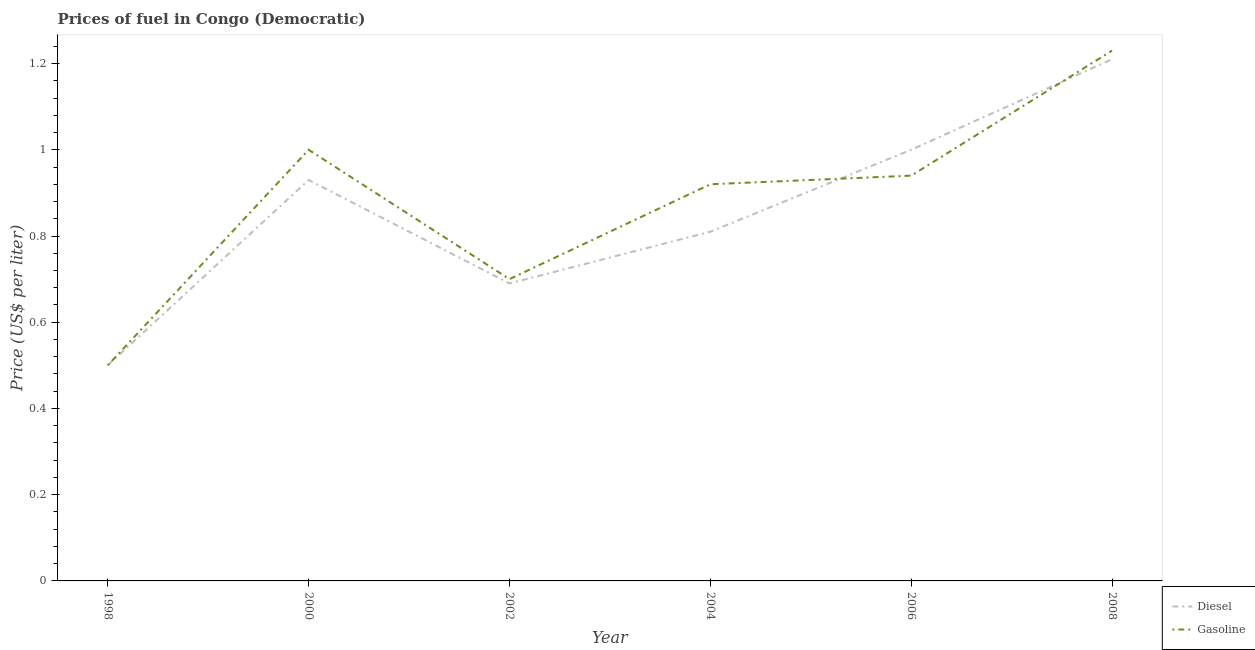Does the line corresponding to gasoline price intersect with the line corresponding to diesel price?
Your response must be concise. Yes. Is the number of lines equal to the number of legend labels?
Offer a very short reply. Yes. What is the gasoline price in 2000?
Your answer should be compact. 1. Across all years, what is the maximum diesel price?
Provide a short and direct response. 1.21. Across all years, what is the minimum gasoline price?
Provide a short and direct response. 0.5. What is the total diesel price in the graph?
Ensure brevity in your answer.  5.14. What is the difference between the gasoline price in 1998 and that in 2004?
Ensure brevity in your answer.  -0.42. What is the difference between the diesel price in 2002 and the gasoline price in 2006?
Offer a very short reply. -0.25. What is the average diesel price per year?
Make the answer very short. 0.86. In the year 2006, what is the difference between the gasoline price and diesel price?
Offer a terse response. -0.06. In how many years, is the gasoline price greater than 1.08 US$ per litre?
Ensure brevity in your answer.  1. What is the ratio of the diesel price in 1998 to that in 2008?
Offer a terse response. 0.41. Is the gasoline price in 1998 less than that in 2002?
Your answer should be compact. Yes. What is the difference between the highest and the second highest diesel price?
Make the answer very short. 0.21. What is the difference between the highest and the lowest diesel price?
Make the answer very short. 0.71. Does the gasoline price monotonically increase over the years?
Your response must be concise. No. Are the values on the major ticks of Y-axis written in scientific E-notation?
Give a very brief answer. No. Does the graph contain any zero values?
Provide a short and direct response. No. Does the graph contain grids?
Provide a succinct answer. No. Where does the legend appear in the graph?
Make the answer very short. Bottom right. How are the legend labels stacked?
Ensure brevity in your answer.  Vertical. What is the title of the graph?
Your response must be concise. Prices of fuel in Congo (Democratic). What is the label or title of the Y-axis?
Your answer should be compact. Price (US$ per liter). What is the Price (US$ per liter) in Gasoline in 1998?
Keep it short and to the point. 0.5. What is the Price (US$ per liter) of Diesel in 2000?
Provide a succinct answer. 0.93. What is the Price (US$ per liter) in Diesel in 2002?
Your answer should be very brief. 0.69. What is the Price (US$ per liter) of Diesel in 2004?
Offer a terse response. 0.81. What is the Price (US$ per liter) of Diesel in 2008?
Provide a short and direct response. 1.21. What is the Price (US$ per liter) of Gasoline in 2008?
Your answer should be compact. 1.23. Across all years, what is the maximum Price (US$ per liter) of Diesel?
Make the answer very short. 1.21. Across all years, what is the maximum Price (US$ per liter) of Gasoline?
Your answer should be compact. 1.23. What is the total Price (US$ per liter) of Diesel in the graph?
Keep it short and to the point. 5.14. What is the total Price (US$ per liter) in Gasoline in the graph?
Make the answer very short. 5.29. What is the difference between the Price (US$ per liter) in Diesel in 1998 and that in 2000?
Your answer should be very brief. -0.43. What is the difference between the Price (US$ per liter) of Diesel in 1998 and that in 2002?
Your answer should be compact. -0.19. What is the difference between the Price (US$ per liter) in Gasoline in 1998 and that in 2002?
Your response must be concise. -0.2. What is the difference between the Price (US$ per liter) of Diesel in 1998 and that in 2004?
Your answer should be compact. -0.31. What is the difference between the Price (US$ per liter) in Gasoline in 1998 and that in 2004?
Provide a short and direct response. -0.42. What is the difference between the Price (US$ per liter) of Gasoline in 1998 and that in 2006?
Provide a short and direct response. -0.44. What is the difference between the Price (US$ per liter) in Diesel in 1998 and that in 2008?
Your answer should be very brief. -0.71. What is the difference between the Price (US$ per liter) of Gasoline in 1998 and that in 2008?
Your response must be concise. -0.73. What is the difference between the Price (US$ per liter) in Diesel in 2000 and that in 2002?
Offer a terse response. 0.24. What is the difference between the Price (US$ per liter) of Gasoline in 2000 and that in 2002?
Keep it short and to the point. 0.3. What is the difference between the Price (US$ per liter) in Diesel in 2000 and that in 2004?
Make the answer very short. 0.12. What is the difference between the Price (US$ per liter) of Gasoline in 2000 and that in 2004?
Offer a very short reply. 0.08. What is the difference between the Price (US$ per liter) of Diesel in 2000 and that in 2006?
Provide a succinct answer. -0.07. What is the difference between the Price (US$ per liter) of Gasoline in 2000 and that in 2006?
Ensure brevity in your answer.  0.06. What is the difference between the Price (US$ per liter) in Diesel in 2000 and that in 2008?
Provide a short and direct response. -0.28. What is the difference between the Price (US$ per liter) of Gasoline in 2000 and that in 2008?
Provide a short and direct response. -0.23. What is the difference between the Price (US$ per liter) of Diesel in 2002 and that in 2004?
Ensure brevity in your answer.  -0.12. What is the difference between the Price (US$ per liter) in Gasoline in 2002 and that in 2004?
Make the answer very short. -0.22. What is the difference between the Price (US$ per liter) of Diesel in 2002 and that in 2006?
Give a very brief answer. -0.31. What is the difference between the Price (US$ per liter) in Gasoline in 2002 and that in 2006?
Keep it short and to the point. -0.24. What is the difference between the Price (US$ per liter) in Diesel in 2002 and that in 2008?
Ensure brevity in your answer.  -0.52. What is the difference between the Price (US$ per liter) in Gasoline in 2002 and that in 2008?
Ensure brevity in your answer.  -0.53. What is the difference between the Price (US$ per liter) in Diesel in 2004 and that in 2006?
Ensure brevity in your answer.  -0.19. What is the difference between the Price (US$ per liter) of Gasoline in 2004 and that in 2006?
Offer a very short reply. -0.02. What is the difference between the Price (US$ per liter) in Gasoline in 2004 and that in 2008?
Offer a very short reply. -0.31. What is the difference between the Price (US$ per liter) of Diesel in 2006 and that in 2008?
Ensure brevity in your answer.  -0.21. What is the difference between the Price (US$ per liter) of Gasoline in 2006 and that in 2008?
Offer a very short reply. -0.29. What is the difference between the Price (US$ per liter) in Diesel in 1998 and the Price (US$ per liter) in Gasoline in 2000?
Offer a very short reply. -0.5. What is the difference between the Price (US$ per liter) of Diesel in 1998 and the Price (US$ per liter) of Gasoline in 2002?
Your answer should be very brief. -0.2. What is the difference between the Price (US$ per liter) of Diesel in 1998 and the Price (US$ per liter) of Gasoline in 2004?
Your answer should be very brief. -0.42. What is the difference between the Price (US$ per liter) in Diesel in 1998 and the Price (US$ per liter) in Gasoline in 2006?
Provide a succinct answer. -0.44. What is the difference between the Price (US$ per liter) in Diesel in 1998 and the Price (US$ per liter) in Gasoline in 2008?
Provide a short and direct response. -0.73. What is the difference between the Price (US$ per liter) in Diesel in 2000 and the Price (US$ per liter) in Gasoline in 2002?
Your answer should be very brief. 0.23. What is the difference between the Price (US$ per liter) in Diesel in 2000 and the Price (US$ per liter) in Gasoline in 2004?
Your answer should be very brief. 0.01. What is the difference between the Price (US$ per liter) of Diesel in 2000 and the Price (US$ per liter) of Gasoline in 2006?
Your answer should be very brief. -0.01. What is the difference between the Price (US$ per liter) in Diesel in 2002 and the Price (US$ per liter) in Gasoline in 2004?
Give a very brief answer. -0.23. What is the difference between the Price (US$ per liter) of Diesel in 2002 and the Price (US$ per liter) of Gasoline in 2006?
Offer a very short reply. -0.25. What is the difference between the Price (US$ per liter) in Diesel in 2002 and the Price (US$ per liter) in Gasoline in 2008?
Your answer should be very brief. -0.54. What is the difference between the Price (US$ per liter) of Diesel in 2004 and the Price (US$ per liter) of Gasoline in 2006?
Your answer should be compact. -0.13. What is the difference between the Price (US$ per liter) of Diesel in 2004 and the Price (US$ per liter) of Gasoline in 2008?
Offer a very short reply. -0.42. What is the difference between the Price (US$ per liter) in Diesel in 2006 and the Price (US$ per liter) in Gasoline in 2008?
Ensure brevity in your answer.  -0.23. What is the average Price (US$ per liter) of Diesel per year?
Your answer should be very brief. 0.86. What is the average Price (US$ per liter) in Gasoline per year?
Your answer should be compact. 0.88. In the year 2000, what is the difference between the Price (US$ per liter) in Diesel and Price (US$ per liter) in Gasoline?
Your answer should be very brief. -0.07. In the year 2002, what is the difference between the Price (US$ per liter) in Diesel and Price (US$ per liter) in Gasoline?
Your answer should be compact. -0.01. In the year 2004, what is the difference between the Price (US$ per liter) of Diesel and Price (US$ per liter) of Gasoline?
Offer a terse response. -0.11. In the year 2006, what is the difference between the Price (US$ per liter) in Diesel and Price (US$ per liter) in Gasoline?
Provide a succinct answer. 0.06. In the year 2008, what is the difference between the Price (US$ per liter) in Diesel and Price (US$ per liter) in Gasoline?
Keep it short and to the point. -0.02. What is the ratio of the Price (US$ per liter) of Diesel in 1998 to that in 2000?
Offer a very short reply. 0.54. What is the ratio of the Price (US$ per liter) in Diesel in 1998 to that in 2002?
Your answer should be compact. 0.72. What is the ratio of the Price (US$ per liter) in Diesel in 1998 to that in 2004?
Your answer should be compact. 0.62. What is the ratio of the Price (US$ per liter) of Gasoline in 1998 to that in 2004?
Your answer should be compact. 0.54. What is the ratio of the Price (US$ per liter) in Diesel in 1998 to that in 2006?
Ensure brevity in your answer.  0.5. What is the ratio of the Price (US$ per liter) of Gasoline in 1998 to that in 2006?
Your answer should be very brief. 0.53. What is the ratio of the Price (US$ per liter) of Diesel in 1998 to that in 2008?
Your response must be concise. 0.41. What is the ratio of the Price (US$ per liter) of Gasoline in 1998 to that in 2008?
Give a very brief answer. 0.41. What is the ratio of the Price (US$ per liter) in Diesel in 2000 to that in 2002?
Offer a very short reply. 1.35. What is the ratio of the Price (US$ per liter) of Gasoline in 2000 to that in 2002?
Provide a succinct answer. 1.43. What is the ratio of the Price (US$ per liter) in Diesel in 2000 to that in 2004?
Your response must be concise. 1.15. What is the ratio of the Price (US$ per liter) in Gasoline in 2000 to that in 2004?
Your answer should be very brief. 1.09. What is the ratio of the Price (US$ per liter) in Diesel in 2000 to that in 2006?
Give a very brief answer. 0.93. What is the ratio of the Price (US$ per liter) of Gasoline in 2000 to that in 2006?
Ensure brevity in your answer.  1.06. What is the ratio of the Price (US$ per liter) in Diesel in 2000 to that in 2008?
Your answer should be very brief. 0.77. What is the ratio of the Price (US$ per liter) of Gasoline in 2000 to that in 2008?
Give a very brief answer. 0.81. What is the ratio of the Price (US$ per liter) in Diesel in 2002 to that in 2004?
Offer a terse response. 0.85. What is the ratio of the Price (US$ per liter) of Gasoline in 2002 to that in 2004?
Provide a short and direct response. 0.76. What is the ratio of the Price (US$ per liter) in Diesel in 2002 to that in 2006?
Provide a succinct answer. 0.69. What is the ratio of the Price (US$ per liter) of Gasoline in 2002 to that in 2006?
Give a very brief answer. 0.74. What is the ratio of the Price (US$ per liter) of Diesel in 2002 to that in 2008?
Offer a very short reply. 0.57. What is the ratio of the Price (US$ per liter) of Gasoline in 2002 to that in 2008?
Keep it short and to the point. 0.57. What is the ratio of the Price (US$ per liter) of Diesel in 2004 to that in 2006?
Provide a short and direct response. 0.81. What is the ratio of the Price (US$ per liter) in Gasoline in 2004 to that in 2006?
Offer a terse response. 0.98. What is the ratio of the Price (US$ per liter) of Diesel in 2004 to that in 2008?
Your response must be concise. 0.67. What is the ratio of the Price (US$ per liter) in Gasoline in 2004 to that in 2008?
Provide a short and direct response. 0.75. What is the ratio of the Price (US$ per liter) in Diesel in 2006 to that in 2008?
Offer a terse response. 0.83. What is the ratio of the Price (US$ per liter) of Gasoline in 2006 to that in 2008?
Ensure brevity in your answer.  0.76. What is the difference between the highest and the second highest Price (US$ per liter) in Diesel?
Keep it short and to the point. 0.21. What is the difference between the highest and the second highest Price (US$ per liter) of Gasoline?
Give a very brief answer. 0.23. What is the difference between the highest and the lowest Price (US$ per liter) of Diesel?
Keep it short and to the point. 0.71. What is the difference between the highest and the lowest Price (US$ per liter) of Gasoline?
Provide a short and direct response. 0.73. 